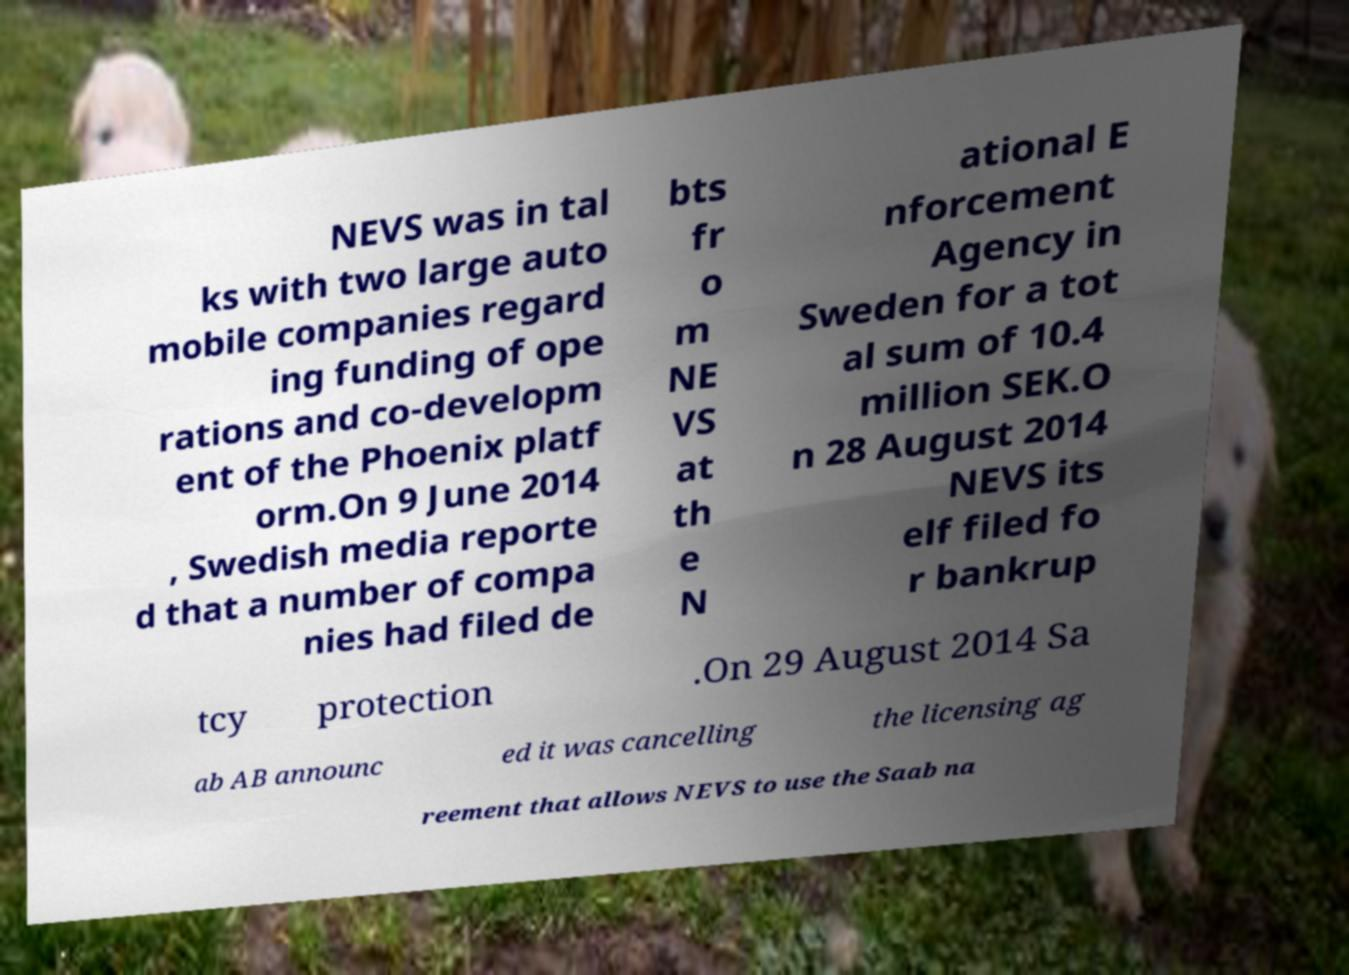Please identify and transcribe the text found in this image. NEVS was in tal ks with two large auto mobile companies regard ing funding of ope rations and co-developm ent of the Phoenix platf orm.On 9 June 2014 , Swedish media reporte d that a number of compa nies had filed de bts fr o m NE VS at th e N ational E nforcement Agency in Sweden for a tot al sum of 10.4 million SEK.O n 28 August 2014 NEVS its elf filed fo r bankrup tcy protection .On 29 August 2014 Sa ab AB announc ed it was cancelling the licensing ag reement that allows NEVS to use the Saab na 